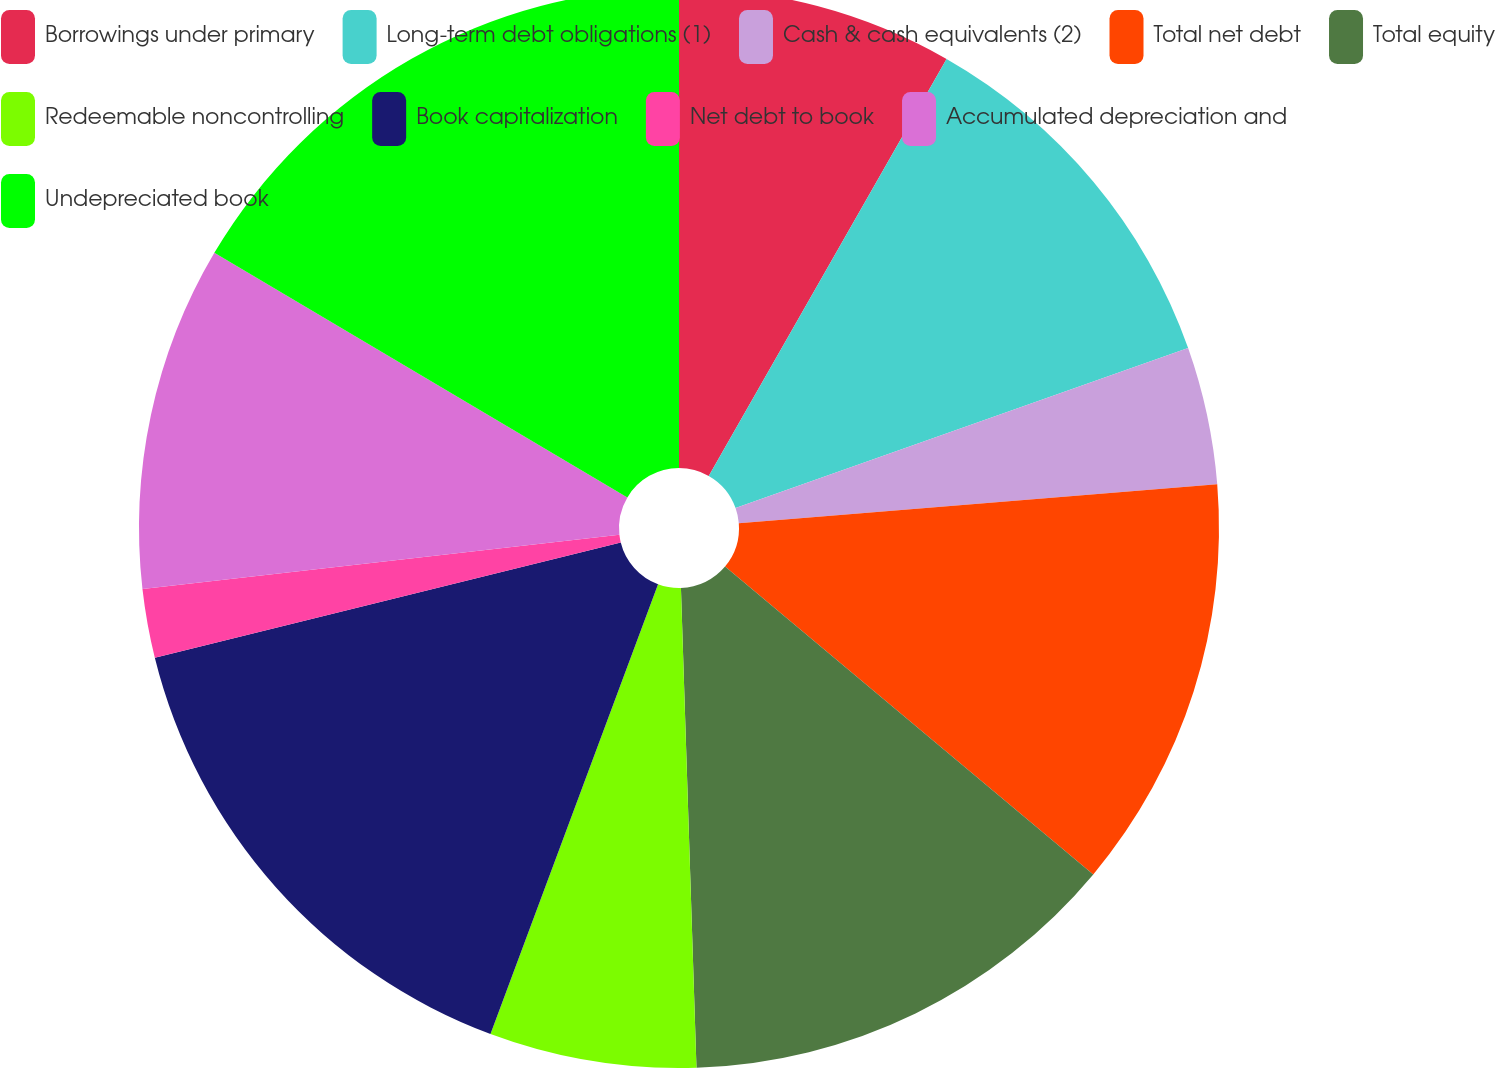Convert chart to OTSL. <chart><loc_0><loc_0><loc_500><loc_500><pie_chart><fcel>Borrowings under primary<fcel>Long-term debt obligations (1)<fcel>Cash & cash equivalents (2)<fcel>Total net debt<fcel>Total equity<fcel>Redeemable noncontrolling<fcel>Book capitalization<fcel>Net debt to book<fcel>Accumulated depreciation and<fcel>Undepreciated book<nl><fcel>8.25%<fcel>11.34%<fcel>4.12%<fcel>12.37%<fcel>13.4%<fcel>6.19%<fcel>15.46%<fcel>2.06%<fcel>10.31%<fcel>16.49%<nl></chart> 